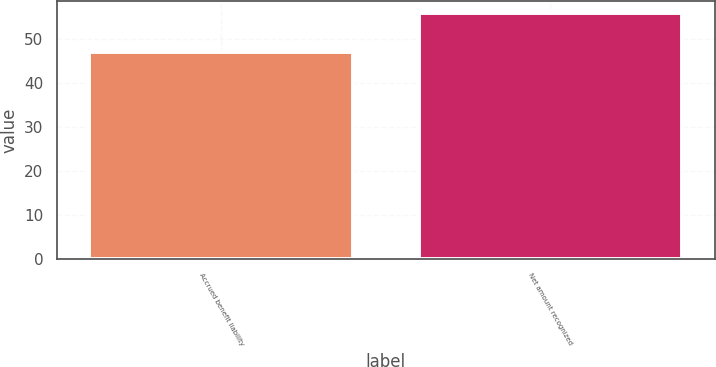Convert chart to OTSL. <chart><loc_0><loc_0><loc_500><loc_500><bar_chart><fcel>Accrued benefit liability<fcel>Net amount recognized<nl><fcel>47<fcel>56<nl></chart> 